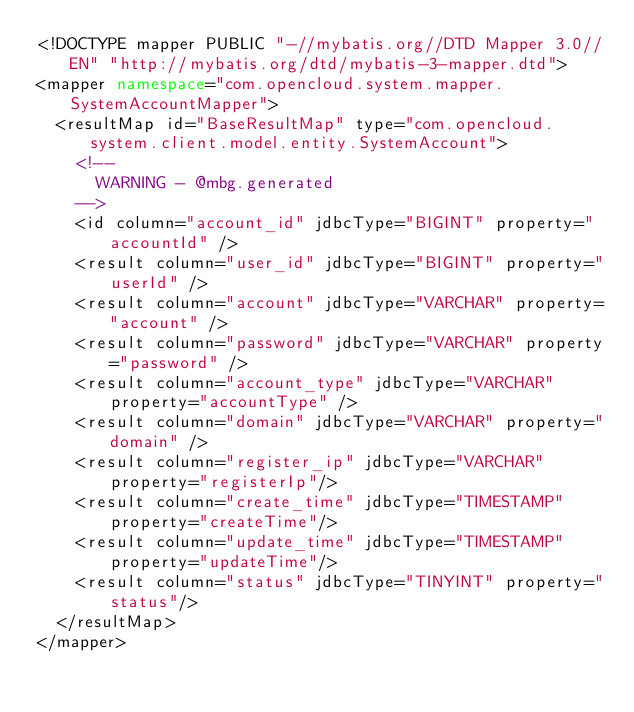<code> <loc_0><loc_0><loc_500><loc_500><_XML_><!DOCTYPE mapper PUBLIC "-//mybatis.org//DTD Mapper 3.0//EN" "http://mybatis.org/dtd/mybatis-3-mapper.dtd">
<mapper namespace="com.opencloud.system.mapper.SystemAccountMapper">
  <resultMap id="BaseResultMap" type="com.opencloud.system.client.model.entity.SystemAccount">
    <!--
      WARNING - @mbg.generated
    -->
    <id column="account_id" jdbcType="BIGINT" property="accountId" />
    <result column="user_id" jdbcType="BIGINT" property="userId" />
    <result column="account" jdbcType="VARCHAR" property="account" />
    <result column="password" jdbcType="VARCHAR" property="password" />
    <result column="account_type" jdbcType="VARCHAR" property="accountType" />
    <result column="domain" jdbcType="VARCHAR" property="domain" />
    <result column="register_ip" jdbcType="VARCHAR" property="registerIp"/>
    <result column="create_time" jdbcType="TIMESTAMP" property="createTime"/>
    <result column="update_time" jdbcType="TIMESTAMP" property="updateTime"/>
    <result column="status" jdbcType="TINYINT" property="status"/>
  </resultMap>
</mapper>
</code> 